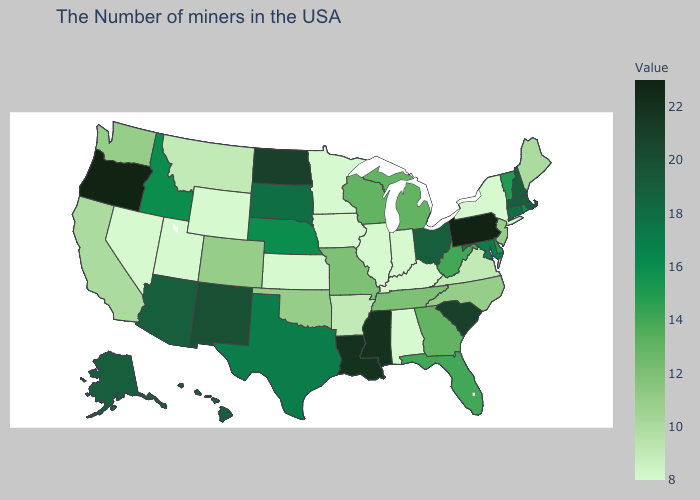Among the states that border Oregon , which have the lowest value?
Short answer required. Nevada. Does Louisiana have the lowest value in the USA?
Quick response, please. No. Among the states that border New Mexico , which have the lowest value?
Concise answer only. Utah. Does the map have missing data?
Be succinct. No. Among the states that border Vermont , does Massachusetts have the lowest value?
Short answer required. No. Is the legend a continuous bar?
Concise answer only. Yes. Does Kentucky have a higher value than California?
Give a very brief answer. No. Among the states that border North Carolina , which have the lowest value?
Answer briefly. Virginia. Which states have the lowest value in the USA?
Answer briefly. New York, Kentucky, Indiana, Alabama, Illinois, Minnesota, Iowa, Kansas, Wyoming, Utah, Nevada. 